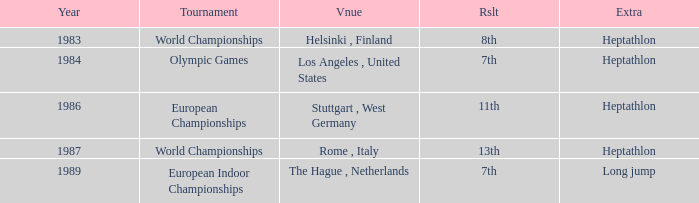How often are the Olympic games hosted? 1984.0. 